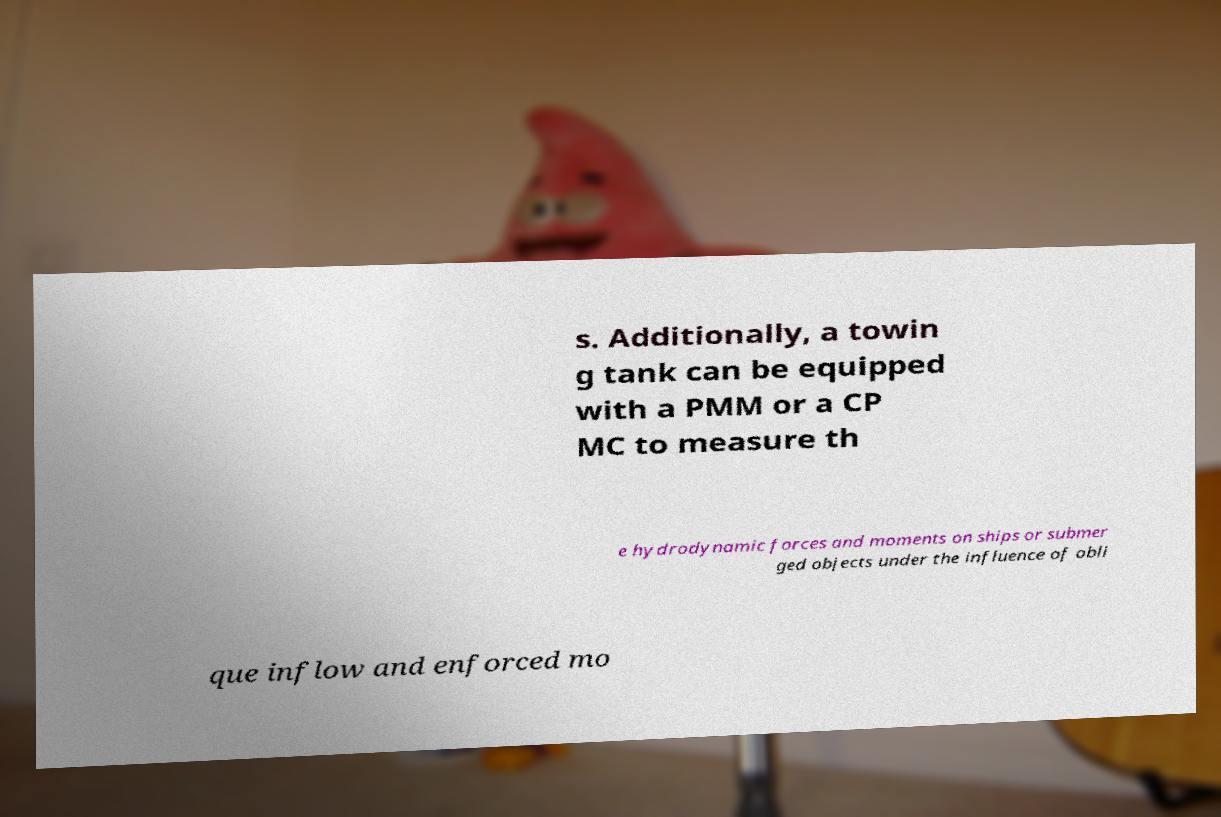There's text embedded in this image that I need extracted. Can you transcribe it verbatim? s. Additionally, a towin g tank can be equipped with a PMM or a CP MC to measure th e hydrodynamic forces and moments on ships or submer ged objects under the influence of obli que inflow and enforced mo 